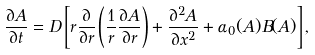Convert formula to latex. <formula><loc_0><loc_0><loc_500><loc_500>\frac { \partial A } { \partial t } = D \left [ r \frac { \partial } { \partial r } \left ( \frac { 1 } { r } \frac { \partial A } { \partial r } \right ) + \frac { \partial ^ { 2 } A } { \partial x ^ { 2 } } + \alpha _ { 0 } ( A ) B ( A ) \right ] ,</formula> 